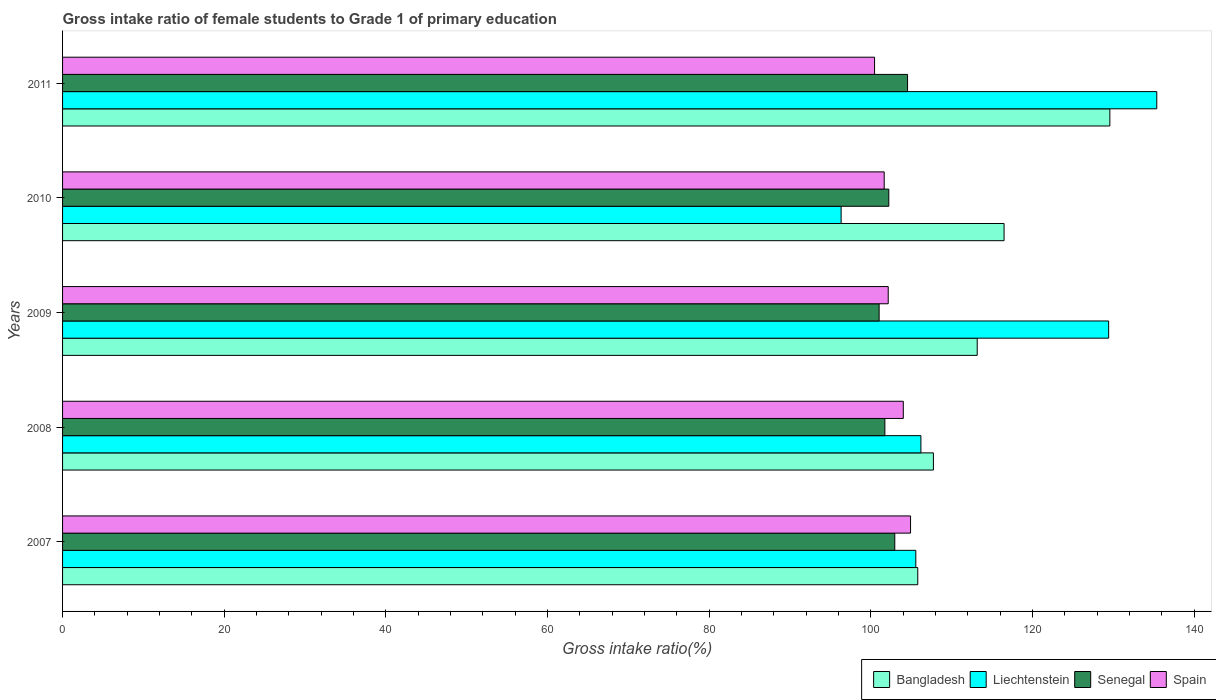How many different coloured bars are there?
Offer a very short reply. 4. How many groups of bars are there?
Offer a very short reply. 5. Are the number of bars per tick equal to the number of legend labels?
Offer a very short reply. Yes. Are the number of bars on each tick of the Y-axis equal?
Keep it short and to the point. Yes. What is the label of the 4th group of bars from the top?
Give a very brief answer. 2008. What is the gross intake ratio in Liechtenstein in 2008?
Keep it short and to the point. 106.19. Across all years, what is the maximum gross intake ratio in Liechtenstein?
Your response must be concise. 135.37. Across all years, what is the minimum gross intake ratio in Spain?
Provide a succinct answer. 100.45. In which year was the gross intake ratio in Bangladesh maximum?
Offer a very short reply. 2011. In which year was the gross intake ratio in Spain minimum?
Give a very brief answer. 2011. What is the total gross intake ratio in Bangladesh in the graph?
Provide a short and direct response. 572.72. What is the difference between the gross intake ratio in Liechtenstein in 2007 and that in 2009?
Your response must be concise. -23.86. What is the difference between the gross intake ratio in Bangladesh in 2010 and the gross intake ratio in Spain in 2011?
Offer a terse response. 16.02. What is the average gross intake ratio in Liechtenstein per year?
Give a very brief answer. 114.57. In the year 2007, what is the difference between the gross intake ratio in Bangladesh and gross intake ratio in Senegal?
Ensure brevity in your answer.  2.84. In how many years, is the gross intake ratio in Spain greater than 40 %?
Provide a short and direct response. 5. What is the ratio of the gross intake ratio in Liechtenstein in 2008 to that in 2011?
Your answer should be compact. 0.78. Is the gross intake ratio in Spain in 2007 less than that in 2009?
Your answer should be compact. No. What is the difference between the highest and the second highest gross intake ratio in Bangladesh?
Ensure brevity in your answer.  13.09. What is the difference between the highest and the lowest gross intake ratio in Liechtenstein?
Your answer should be very brief. 39.05. In how many years, is the gross intake ratio in Spain greater than the average gross intake ratio in Spain taken over all years?
Your answer should be very brief. 2. Is the sum of the gross intake ratio in Senegal in 2008 and 2009 greater than the maximum gross intake ratio in Spain across all years?
Your answer should be compact. Yes. Is it the case that in every year, the sum of the gross intake ratio in Bangladesh and gross intake ratio in Senegal is greater than the sum of gross intake ratio in Spain and gross intake ratio in Liechtenstein?
Provide a short and direct response. Yes. What does the 1st bar from the top in 2011 represents?
Make the answer very short. Spain. What does the 3rd bar from the bottom in 2009 represents?
Give a very brief answer. Senegal. What is the difference between two consecutive major ticks on the X-axis?
Your response must be concise. 20. Does the graph contain any zero values?
Your answer should be very brief. No. Where does the legend appear in the graph?
Provide a short and direct response. Bottom right. How many legend labels are there?
Provide a succinct answer. 4. What is the title of the graph?
Provide a succinct answer. Gross intake ratio of female students to Grade 1 of primary education. Does "Brazil" appear as one of the legend labels in the graph?
Offer a very short reply. No. What is the label or title of the X-axis?
Offer a very short reply. Gross intake ratio(%). What is the label or title of the Y-axis?
Your response must be concise. Years. What is the Gross intake ratio(%) in Bangladesh in 2007?
Your response must be concise. 105.8. What is the Gross intake ratio(%) in Liechtenstein in 2007?
Keep it short and to the point. 105.56. What is the Gross intake ratio(%) in Senegal in 2007?
Make the answer very short. 102.95. What is the Gross intake ratio(%) in Spain in 2007?
Your answer should be compact. 104.9. What is the Gross intake ratio(%) in Bangladesh in 2008?
Give a very brief answer. 107.73. What is the Gross intake ratio(%) in Liechtenstein in 2008?
Provide a short and direct response. 106.19. What is the Gross intake ratio(%) of Senegal in 2008?
Make the answer very short. 101.73. What is the Gross intake ratio(%) in Spain in 2008?
Your answer should be very brief. 104.01. What is the Gross intake ratio(%) of Bangladesh in 2009?
Offer a very short reply. 113.15. What is the Gross intake ratio(%) of Liechtenstein in 2009?
Provide a succinct answer. 129.41. What is the Gross intake ratio(%) in Senegal in 2009?
Provide a succinct answer. 101.02. What is the Gross intake ratio(%) in Spain in 2009?
Ensure brevity in your answer.  102.14. What is the Gross intake ratio(%) in Bangladesh in 2010?
Ensure brevity in your answer.  116.47. What is the Gross intake ratio(%) of Liechtenstein in 2010?
Offer a very short reply. 96.32. What is the Gross intake ratio(%) of Senegal in 2010?
Offer a very short reply. 102.21. What is the Gross intake ratio(%) of Spain in 2010?
Provide a succinct answer. 101.64. What is the Gross intake ratio(%) in Bangladesh in 2011?
Your answer should be compact. 129.56. What is the Gross intake ratio(%) in Liechtenstein in 2011?
Ensure brevity in your answer.  135.37. What is the Gross intake ratio(%) in Senegal in 2011?
Keep it short and to the point. 104.53. What is the Gross intake ratio(%) of Spain in 2011?
Ensure brevity in your answer.  100.45. Across all years, what is the maximum Gross intake ratio(%) in Bangladesh?
Keep it short and to the point. 129.56. Across all years, what is the maximum Gross intake ratio(%) of Liechtenstein?
Offer a very short reply. 135.37. Across all years, what is the maximum Gross intake ratio(%) of Senegal?
Your answer should be compact. 104.53. Across all years, what is the maximum Gross intake ratio(%) in Spain?
Offer a terse response. 104.9. Across all years, what is the minimum Gross intake ratio(%) in Bangladesh?
Provide a succinct answer. 105.8. Across all years, what is the minimum Gross intake ratio(%) of Liechtenstein?
Provide a succinct answer. 96.32. Across all years, what is the minimum Gross intake ratio(%) of Senegal?
Your answer should be compact. 101.02. Across all years, what is the minimum Gross intake ratio(%) of Spain?
Your answer should be very brief. 100.45. What is the total Gross intake ratio(%) of Bangladesh in the graph?
Give a very brief answer. 572.72. What is the total Gross intake ratio(%) of Liechtenstein in the graph?
Ensure brevity in your answer.  572.83. What is the total Gross intake ratio(%) in Senegal in the graph?
Provide a short and direct response. 512.45. What is the total Gross intake ratio(%) in Spain in the graph?
Give a very brief answer. 513.15. What is the difference between the Gross intake ratio(%) in Bangladesh in 2007 and that in 2008?
Your answer should be very brief. -1.94. What is the difference between the Gross intake ratio(%) of Liechtenstein in 2007 and that in 2008?
Give a very brief answer. -0.63. What is the difference between the Gross intake ratio(%) in Senegal in 2007 and that in 2008?
Your answer should be very brief. 1.22. What is the difference between the Gross intake ratio(%) in Spain in 2007 and that in 2008?
Your answer should be very brief. 0.9. What is the difference between the Gross intake ratio(%) in Bangladesh in 2007 and that in 2009?
Provide a succinct answer. -7.36. What is the difference between the Gross intake ratio(%) in Liechtenstein in 2007 and that in 2009?
Provide a succinct answer. -23.86. What is the difference between the Gross intake ratio(%) in Senegal in 2007 and that in 2009?
Provide a succinct answer. 1.94. What is the difference between the Gross intake ratio(%) in Spain in 2007 and that in 2009?
Make the answer very short. 2.76. What is the difference between the Gross intake ratio(%) in Bangladesh in 2007 and that in 2010?
Your answer should be very brief. -10.68. What is the difference between the Gross intake ratio(%) in Liechtenstein in 2007 and that in 2010?
Make the answer very short. 9.24. What is the difference between the Gross intake ratio(%) of Senegal in 2007 and that in 2010?
Keep it short and to the point. 0.74. What is the difference between the Gross intake ratio(%) of Spain in 2007 and that in 2010?
Keep it short and to the point. 3.26. What is the difference between the Gross intake ratio(%) of Bangladesh in 2007 and that in 2011?
Your answer should be compact. -23.76. What is the difference between the Gross intake ratio(%) in Liechtenstein in 2007 and that in 2011?
Ensure brevity in your answer.  -29.81. What is the difference between the Gross intake ratio(%) of Senegal in 2007 and that in 2011?
Your answer should be very brief. -1.58. What is the difference between the Gross intake ratio(%) in Spain in 2007 and that in 2011?
Make the answer very short. 4.45. What is the difference between the Gross intake ratio(%) of Bangladesh in 2008 and that in 2009?
Ensure brevity in your answer.  -5.42. What is the difference between the Gross intake ratio(%) in Liechtenstein in 2008 and that in 2009?
Offer a very short reply. -23.23. What is the difference between the Gross intake ratio(%) of Senegal in 2008 and that in 2009?
Provide a succinct answer. 0.71. What is the difference between the Gross intake ratio(%) in Spain in 2008 and that in 2009?
Your answer should be very brief. 1.87. What is the difference between the Gross intake ratio(%) in Bangladesh in 2008 and that in 2010?
Your answer should be compact. -8.74. What is the difference between the Gross intake ratio(%) of Liechtenstein in 2008 and that in 2010?
Give a very brief answer. 9.87. What is the difference between the Gross intake ratio(%) of Senegal in 2008 and that in 2010?
Your response must be concise. -0.48. What is the difference between the Gross intake ratio(%) in Spain in 2008 and that in 2010?
Your answer should be very brief. 2.36. What is the difference between the Gross intake ratio(%) of Bangladesh in 2008 and that in 2011?
Offer a very short reply. -21.83. What is the difference between the Gross intake ratio(%) of Liechtenstein in 2008 and that in 2011?
Offer a very short reply. -29.18. What is the difference between the Gross intake ratio(%) of Senegal in 2008 and that in 2011?
Your answer should be very brief. -2.81. What is the difference between the Gross intake ratio(%) of Spain in 2008 and that in 2011?
Provide a short and direct response. 3.55. What is the difference between the Gross intake ratio(%) in Bangladesh in 2009 and that in 2010?
Your answer should be very brief. -3.32. What is the difference between the Gross intake ratio(%) in Liechtenstein in 2009 and that in 2010?
Offer a terse response. 33.1. What is the difference between the Gross intake ratio(%) of Senegal in 2009 and that in 2010?
Ensure brevity in your answer.  -1.2. What is the difference between the Gross intake ratio(%) of Spain in 2009 and that in 2010?
Your answer should be very brief. 0.5. What is the difference between the Gross intake ratio(%) of Bangladesh in 2009 and that in 2011?
Your response must be concise. -16.41. What is the difference between the Gross intake ratio(%) in Liechtenstein in 2009 and that in 2011?
Provide a succinct answer. -5.95. What is the difference between the Gross intake ratio(%) in Senegal in 2009 and that in 2011?
Offer a terse response. -3.52. What is the difference between the Gross intake ratio(%) of Spain in 2009 and that in 2011?
Provide a short and direct response. 1.69. What is the difference between the Gross intake ratio(%) of Bangladesh in 2010 and that in 2011?
Give a very brief answer. -13.09. What is the difference between the Gross intake ratio(%) of Liechtenstein in 2010 and that in 2011?
Provide a succinct answer. -39.05. What is the difference between the Gross intake ratio(%) of Senegal in 2010 and that in 2011?
Offer a terse response. -2.32. What is the difference between the Gross intake ratio(%) in Spain in 2010 and that in 2011?
Provide a succinct answer. 1.19. What is the difference between the Gross intake ratio(%) in Bangladesh in 2007 and the Gross intake ratio(%) in Liechtenstein in 2008?
Ensure brevity in your answer.  -0.39. What is the difference between the Gross intake ratio(%) of Bangladesh in 2007 and the Gross intake ratio(%) of Senegal in 2008?
Offer a terse response. 4.07. What is the difference between the Gross intake ratio(%) of Bangladesh in 2007 and the Gross intake ratio(%) of Spain in 2008?
Provide a succinct answer. 1.79. What is the difference between the Gross intake ratio(%) of Liechtenstein in 2007 and the Gross intake ratio(%) of Senegal in 2008?
Your answer should be compact. 3.83. What is the difference between the Gross intake ratio(%) in Liechtenstein in 2007 and the Gross intake ratio(%) in Spain in 2008?
Provide a succinct answer. 1.55. What is the difference between the Gross intake ratio(%) of Senegal in 2007 and the Gross intake ratio(%) of Spain in 2008?
Ensure brevity in your answer.  -1.05. What is the difference between the Gross intake ratio(%) in Bangladesh in 2007 and the Gross intake ratio(%) in Liechtenstein in 2009?
Your response must be concise. -23.61. What is the difference between the Gross intake ratio(%) of Bangladesh in 2007 and the Gross intake ratio(%) of Senegal in 2009?
Your response must be concise. 4.78. What is the difference between the Gross intake ratio(%) in Bangladesh in 2007 and the Gross intake ratio(%) in Spain in 2009?
Ensure brevity in your answer.  3.66. What is the difference between the Gross intake ratio(%) of Liechtenstein in 2007 and the Gross intake ratio(%) of Senegal in 2009?
Make the answer very short. 4.54. What is the difference between the Gross intake ratio(%) in Liechtenstein in 2007 and the Gross intake ratio(%) in Spain in 2009?
Your response must be concise. 3.41. What is the difference between the Gross intake ratio(%) in Senegal in 2007 and the Gross intake ratio(%) in Spain in 2009?
Your answer should be compact. 0.81. What is the difference between the Gross intake ratio(%) of Bangladesh in 2007 and the Gross intake ratio(%) of Liechtenstein in 2010?
Make the answer very short. 9.48. What is the difference between the Gross intake ratio(%) in Bangladesh in 2007 and the Gross intake ratio(%) in Senegal in 2010?
Give a very brief answer. 3.58. What is the difference between the Gross intake ratio(%) of Bangladesh in 2007 and the Gross intake ratio(%) of Spain in 2010?
Ensure brevity in your answer.  4.15. What is the difference between the Gross intake ratio(%) in Liechtenstein in 2007 and the Gross intake ratio(%) in Senegal in 2010?
Offer a terse response. 3.34. What is the difference between the Gross intake ratio(%) in Liechtenstein in 2007 and the Gross intake ratio(%) in Spain in 2010?
Offer a very short reply. 3.91. What is the difference between the Gross intake ratio(%) of Senegal in 2007 and the Gross intake ratio(%) of Spain in 2010?
Make the answer very short. 1.31. What is the difference between the Gross intake ratio(%) in Bangladesh in 2007 and the Gross intake ratio(%) in Liechtenstein in 2011?
Offer a very short reply. -29.57. What is the difference between the Gross intake ratio(%) in Bangladesh in 2007 and the Gross intake ratio(%) in Senegal in 2011?
Provide a succinct answer. 1.26. What is the difference between the Gross intake ratio(%) in Bangladesh in 2007 and the Gross intake ratio(%) in Spain in 2011?
Provide a succinct answer. 5.34. What is the difference between the Gross intake ratio(%) of Liechtenstein in 2007 and the Gross intake ratio(%) of Senegal in 2011?
Provide a succinct answer. 1.02. What is the difference between the Gross intake ratio(%) of Liechtenstein in 2007 and the Gross intake ratio(%) of Spain in 2011?
Keep it short and to the point. 5.1. What is the difference between the Gross intake ratio(%) in Senegal in 2007 and the Gross intake ratio(%) in Spain in 2011?
Give a very brief answer. 2.5. What is the difference between the Gross intake ratio(%) in Bangladesh in 2008 and the Gross intake ratio(%) in Liechtenstein in 2009?
Offer a terse response. -21.68. What is the difference between the Gross intake ratio(%) of Bangladesh in 2008 and the Gross intake ratio(%) of Senegal in 2009?
Make the answer very short. 6.72. What is the difference between the Gross intake ratio(%) in Bangladesh in 2008 and the Gross intake ratio(%) in Spain in 2009?
Your answer should be compact. 5.59. What is the difference between the Gross intake ratio(%) of Liechtenstein in 2008 and the Gross intake ratio(%) of Senegal in 2009?
Provide a succinct answer. 5.17. What is the difference between the Gross intake ratio(%) in Liechtenstein in 2008 and the Gross intake ratio(%) in Spain in 2009?
Your answer should be very brief. 4.04. What is the difference between the Gross intake ratio(%) in Senegal in 2008 and the Gross intake ratio(%) in Spain in 2009?
Make the answer very short. -0.41. What is the difference between the Gross intake ratio(%) in Bangladesh in 2008 and the Gross intake ratio(%) in Liechtenstein in 2010?
Your answer should be very brief. 11.42. What is the difference between the Gross intake ratio(%) in Bangladesh in 2008 and the Gross intake ratio(%) in Senegal in 2010?
Offer a terse response. 5.52. What is the difference between the Gross intake ratio(%) of Bangladesh in 2008 and the Gross intake ratio(%) of Spain in 2010?
Your answer should be very brief. 6.09. What is the difference between the Gross intake ratio(%) in Liechtenstein in 2008 and the Gross intake ratio(%) in Senegal in 2010?
Your answer should be very brief. 3.97. What is the difference between the Gross intake ratio(%) of Liechtenstein in 2008 and the Gross intake ratio(%) of Spain in 2010?
Provide a succinct answer. 4.54. What is the difference between the Gross intake ratio(%) of Senegal in 2008 and the Gross intake ratio(%) of Spain in 2010?
Your answer should be very brief. 0.08. What is the difference between the Gross intake ratio(%) in Bangladesh in 2008 and the Gross intake ratio(%) in Liechtenstein in 2011?
Give a very brief answer. -27.63. What is the difference between the Gross intake ratio(%) of Bangladesh in 2008 and the Gross intake ratio(%) of Senegal in 2011?
Keep it short and to the point. 3.2. What is the difference between the Gross intake ratio(%) in Bangladesh in 2008 and the Gross intake ratio(%) in Spain in 2011?
Your answer should be very brief. 7.28. What is the difference between the Gross intake ratio(%) of Liechtenstein in 2008 and the Gross intake ratio(%) of Senegal in 2011?
Your answer should be compact. 1.65. What is the difference between the Gross intake ratio(%) in Liechtenstein in 2008 and the Gross intake ratio(%) in Spain in 2011?
Your answer should be very brief. 5.73. What is the difference between the Gross intake ratio(%) of Senegal in 2008 and the Gross intake ratio(%) of Spain in 2011?
Offer a very short reply. 1.28. What is the difference between the Gross intake ratio(%) in Bangladesh in 2009 and the Gross intake ratio(%) in Liechtenstein in 2010?
Keep it short and to the point. 16.84. What is the difference between the Gross intake ratio(%) in Bangladesh in 2009 and the Gross intake ratio(%) in Senegal in 2010?
Ensure brevity in your answer.  10.94. What is the difference between the Gross intake ratio(%) in Bangladesh in 2009 and the Gross intake ratio(%) in Spain in 2010?
Make the answer very short. 11.51. What is the difference between the Gross intake ratio(%) of Liechtenstein in 2009 and the Gross intake ratio(%) of Senegal in 2010?
Your response must be concise. 27.2. What is the difference between the Gross intake ratio(%) of Liechtenstein in 2009 and the Gross intake ratio(%) of Spain in 2010?
Your answer should be very brief. 27.77. What is the difference between the Gross intake ratio(%) of Senegal in 2009 and the Gross intake ratio(%) of Spain in 2010?
Offer a terse response. -0.63. What is the difference between the Gross intake ratio(%) of Bangladesh in 2009 and the Gross intake ratio(%) of Liechtenstein in 2011?
Your answer should be very brief. -22.21. What is the difference between the Gross intake ratio(%) in Bangladesh in 2009 and the Gross intake ratio(%) in Senegal in 2011?
Give a very brief answer. 8.62. What is the difference between the Gross intake ratio(%) in Bangladesh in 2009 and the Gross intake ratio(%) in Spain in 2011?
Give a very brief answer. 12.7. What is the difference between the Gross intake ratio(%) in Liechtenstein in 2009 and the Gross intake ratio(%) in Senegal in 2011?
Your answer should be very brief. 24.88. What is the difference between the Gross intake ratio(%) in Liechtenstein in 2009 and the Gross intake ratio(%) in Spain in 2011?
Offer a very short reply. 28.96. What is the difference between the Gross intake ratio(%) in Senegal in 2009 and the Gross intake ratio(%) in Spain in 2011?
Offer a terse response. 0.56. What is the difference between the Gross intake ratio(%) of Bangladesh in 2010 and the Gross intake ratio(%) of Liechtenstein in 2011?
Offer a terse response. -18.89. What is the difference between the Gross intake ratio(%) of Bangladesh in 2010 and the Gross intake ratio(%) of Senegal in 2011?
Provide a succinct answer. 11.94. What is the difference between the Gross intake ratio(%) in Bangladesh in 2010 and the Gross intake ratio(%) in Spain in 2011?
Ensure brevity in your answer.  16.02. What is the difference between the Gross intake ratio(%) in Liechtenstein in 2010 and the Gross intake ratio(%) in Senegal in 2011?
Provide a short and direct response. -8.22. What is the difference between the Gross intake ratio(%) in Liechtenstein in 2010 and the Gross intake ratio(%) in Spain in 2011?
Your response must be concise. -4.14. What is the difference between the Gross intake ratio(%) in Senegal in 2010 and the Gross intake ratio(%) in Spain in 2011?
Your response must be concise. 1.76. What is the average Gross intake ratio(%) in Bangladesh per year?
Give a very brief answer. 114.54. What is the average Gross intake ratio(%) of Liechtenstein per year?
Your answer should be compact. 114.57. What is the average Gross intake ratio(%) of Senegal per year?
Your answer should be compact. 102.49. What is the average Gross intake ratio(%) in Spain per year?
Provide a short and direct response. 102.63. In the year 2007, what is the difference between the Gross intake ratio(%) of Bangladesh and Gross intake ratio(%) of Liechtenstein?
Make the answer very short. 0.24. In the year 2007, what is the difference between the Gross intake ratio(%) of Bangladesh and Gross intake ratio(%) of Senegal?
Provide a succinct answer. 2.84. In the year 2007, what is the difference between the Gross intake ratio(%) of Bangladesh and Gross intake ratio(%) of Spain?
Your answer should be compact. 0.89. In the year 2007, what is the difference between the Gross intake ratio(%) of Liechtenstein and Gross intake ratio(%) of Senegal?
Keep it short and to the point. 2.6. In the year 2007, what is the difference between the Gross intake ratio(%) of Liechtenstein and Gross intake ratio(%) of Spain?
Provide a short and direct response. 0.65. In the year 2007, what is the difference between the Gross intake ratio(%) in Senegal and Gross intake ratio(%) in Spain?
Your response must be concise. -1.95. In the year 2008, what is the difference between the Gross intake ratio(%) in Bangladesh and Gross intake ratio(%) in Liechtenstein?
Make the answer very short. 1.55. In the year 2008, what is the difference between the Gross intake ratio(%) in Bangladesh and Gross intake ratio(%) in Senegal?
Ensure brevity in your answer.  6. In the year 2008, what is the difference between the Gross intake ratio(%) of Bangladesh and Gross intake ratio(%) of Spain?
Your response must be concise. 3.73. In the year 2008, what is the difference between the Gross intake ratio(%) in Liechtenstein and Gross intake ratio(%) in Senegal?
Provide a short and direct response. 4.46. In the year 2008, what is the difference between the Gross intake ratio(%) in Liechtenstein and Gross intake ratio(%) in Spain?
Your answer should be compact. 2.18. In the year 2008, what is the difference between the Gross intake ratio(%) in Senegal and Gross intake ratio(%) in Spain?
Your answer should be very brief. -2.28. In the year 2009, what is the difference between the Gross intake ratio(%) of Bangladesh and Gross intake ratio(%) of Liechtenstein?
Make the answer very short. -16.26. In the year 2009, what is the difference between the Gross intake ratio(%) in Bangladesh and Gross intake ratio(%) in Senegal?
Provide a succinct answer. 12.13. In the year 2009, what is the difference between the Gross intake ratio(%) of Bangladesh and Gross intake ratio(%) of Spain?
Provide a short and direct response. 11.01. In the year 2009, what is the difference between the Gross intake ratio(%) of Liechtenstein and Gross intake ratio(%) of Senegal?
Ensure brevity in your answer.  28.39. In the year 2009, what is the difference between the Gross intake ratio(%) of Liechtenstein and Gross intake ratio(%) of Spain?
Offer a very short reply. 27.27. In the year 2009, what is the difference between the Gross intake ratio(%) of Senegal and Gross intake ratio(%) of Spain?
Your answer should be very brief. -1.12. In the year 2010, what is the difference between the Gross intake ratio(%) in Bangladesh and Gross intake ratio(%) in Liechtenstein?
Your answer should be very brief. 20.16. In the year 2010, what is the difference between the Gross intake ratio(%) in Bangladesh and Gross intake ratio(%) in Senegal?
Your answer should be compact. 14.26. In the year 2010, what is the difference between the Gross intake ratio(%) of Bangladesh and Gross intake ratio(%) of Spain?
Make the answer very short. 14.83. In the year 2010, what is the difference between the Gross intake ratio(%) in Liechtenstein and Gross intake ratio(%) in Senegal?
Make the answer very short. -5.9. In the year 2010, what is the difference between the Gross intake ratio(%) in Liechtenstein and Gross intake ratio(%) in Spain?
Offer a terse response. -5.33. In the year 2010, what is the difference between the Gross intake ratio(%) of Senegal and Gross intake ratio(%) of Spain?
Your answer should be compact. 0.57. In the year 2011, what is the difference between the Gross intake ratio(%) in Bangladesh and Gross intake ratio(%) in Liechtenstein?
Keep it short and to the point. -5.8. In the year 2011, what is the difference between the Gross intake ratio(%) of Bangladesh and Gross intake ratio(%) of Senegal?
Give a very brief answer. 25.03. In the year 2011, what is the difference between the Gross intake ratio(%) in Bangladesh and Gross intake ratio(%) in Spain?
Ensure brevity in your answer.  29.11. In the year 2011, what is the difference between the Gross intake ratio(%) of Liechtenstein and Gross intake ratio(%) of Senegal?
Offer a very short reply. 30.83. In the year 2011, what is the difference between the Gross intake ratio(%) of Liechtenstein and Gross intake ratio(%) of Spain?
Ensure brevity in your answer.  34.91. In the year 2011, what is the difference between the Gross intake ratio(%) of Senegal and Gross intake ratio(%) of Spain?
Offer a very short reply. 4.08. What is the ratio of the Gross intake ratio(%) in Bangladesh in 2007 to that in 2008?
Offer a very short reply. 0.98. What is the ratio of the Gross intake ratio(%) in Spain in 2007 to that in 2008?
Give a very brief answer. 1.01. What is the ratio of the Gross intake ratio(%) in Bangladesh in 2007 to that in 2009?
Give a very brief answer. 0.94. What is the ratio of the Gross intake ratio(%) in Liechtenstein in 2007 to that in 2009?
Your answer should be compact. 0.82. What is the ratio of the Gross intake ratio(%) of Senegal in 2007 to that in 2009?
Offer a terse response. 1.02. What is the ratio of the Gross intake ratio(%) in Bangladesh in 2007 to that in 2010?
Ensure brevity in your answer.  0.91. What is the ratio of the Gross intake ratio(%) in Liechtenstein in 2007 to that in 2010?
Keep it short and to the point. 1.1. What is the ratio of the Gross intake ratio(%) in Senegal in 2007 to that in 2010?
Give a very brief answer. 1.01. What is the ratio of the Gross intake ratio(%) in Spain in 2007 to that in 2010?
Your answer should be very brief. 1.03. What is the ratio of the Gross intake ratio(%) of Bangladesh in 2007 to that in 2011?
Keep it short and to the point. 0.82. What is the ratio of the Gross intake ratio(%) in Liechtenstein in 2007 to that in 2011?
Your answer should be very brief. 0.78. What is the ratio of the Gross intake ratio(%) of Senegal in 2007 to that in 2011?
Make the answer very short. 0.98. What is the ratio of the Gross intake ratio(%) of Spain in 2007 to that in 2011?
Make the answer very short. 1.04. What is the ratio of the Gross intake ratio(%) of Bangladesh in 2008 to that in 2009?
Your response must be concise. 0.95. What is the ratio of the Gross intake ratio(%) in Liechtenstein in 2008 to that in 2009?
Your response must be concise. 0.82. What is the ratio of the Gross intake ratio(%) of Spain in 2008 to that in 2009?
Provide a short and direct response. 1.02. What is the ratio of the Gross intake ratio(%) in Bangladesh in 2008 to that in 2010?
Your response must be concise. 0.92. What is the ratio of the Gross intake ratio(%) of Liechtenstein in 2008 to that in 2010?
Your answer should be very brief. 1.1. What is the ratio of the Gross intake ratio(%) in Spain in 2008 to that in 2010?
Ensure brevity in your answer.  1.02. What is the ratio of the Gross intake ratio(%) in Bangladesh in 2008 to that in 2011?
Give a very brief answer. 0.83. What is the ratio of the Gross intake ratio(%) in Liechtenstein in 2008 to that in 2011?
Give a very brief answer. 0.78. What is the ratio of the Gross intake ratio(%) of Senegal in 2008 to that in 2011?
Your response must be concise. 0.97. What is the ratio of the Gross intake ratio(%) of Spain in 2008 to that in 2011?
Keep it short and to the point. 1.04. What is the ratio of the Gross intake ratio(%) in Bangladesh in 2009 to that in 2010?
Your answer should be compact. 0.97. What is the ratio of the Gross intake ratio(%) in Liechtenstein in 2009 to that in 2010?
Your answer should be very brief. 1.34. What is the ratio of the Gross intake ratio(%) of Senegal in 2009 to that in 2010?
Provide a succinct answer. 0.99. What is the ratio of the Gross intake ratio(%) in Bangladesh in 2009 to that in 2011?
Give a very brief answer. 0.87. What is the ratio of the Gross intake ratio(%) in Liechtenstein in 2009 to that in 2011?
Provide a short and direct response. 0.96. What is the ratio of the Gross intake ratio(%) of Senegal in 2009 to that in 2011?
Your answer should be very brief. 0.97. What is the ratio of the Gross intake ratio(%) of Spain in 2009 to that in 2011?
Make the answer very short. 1.02. What is the ratio of the Gross intake ratio(%) of Bangladesh in 2010 to that in 2011?
Your response must be concise. 0.9. What is the ratio of the Gross intake ratio(%) in Liechtenstein in 2010 to that in 2011?
Provide a short and direct response. 0.71. What is the ratio of the Gross intake ratio(%) of Senegal in 2010 to that in 2011?
Offer a very short reply. 0.98. What is the ratio of the Gross intake ratio(%) of Spain in 2010 to that in 2011?
Keep it short and to the point. 1.01. What is the difference between the highest and the second highest Gross intake ratio(%) of Bangladesh?
Provide a short and direct response. 13.09. What is the difference between the highest and the second highest Gross intake ratio(%) in Liechtenstein?
Ensure brevity in your answer.  5.95. What is the difference between the highest and the second highest Gross intake ratio(%) in Senegal?
Provide a succinct answer. 1.58. What is the difference between the highest and the second highest Gross intake ratio(%) in Spain?
Offer a very short reply. 0.9. What is the difference between the highest and the lowest Gross intake ratio(%) in Bangladesh?
Offer a terse response. 23.76. What is the difference between the highest and the lowest Gross intake ratio(%) of Liechtenstein?
Provide a short and direct response. 39.05. What is the difference between the highest and the lowest Gross intake ratio(%) of Senegal?
Your answer should be compact. 3.52. What is the difference between the highest and the lowest Gross intake ratio(%) of Spain?
Keep it short and to the point. 4.45. 